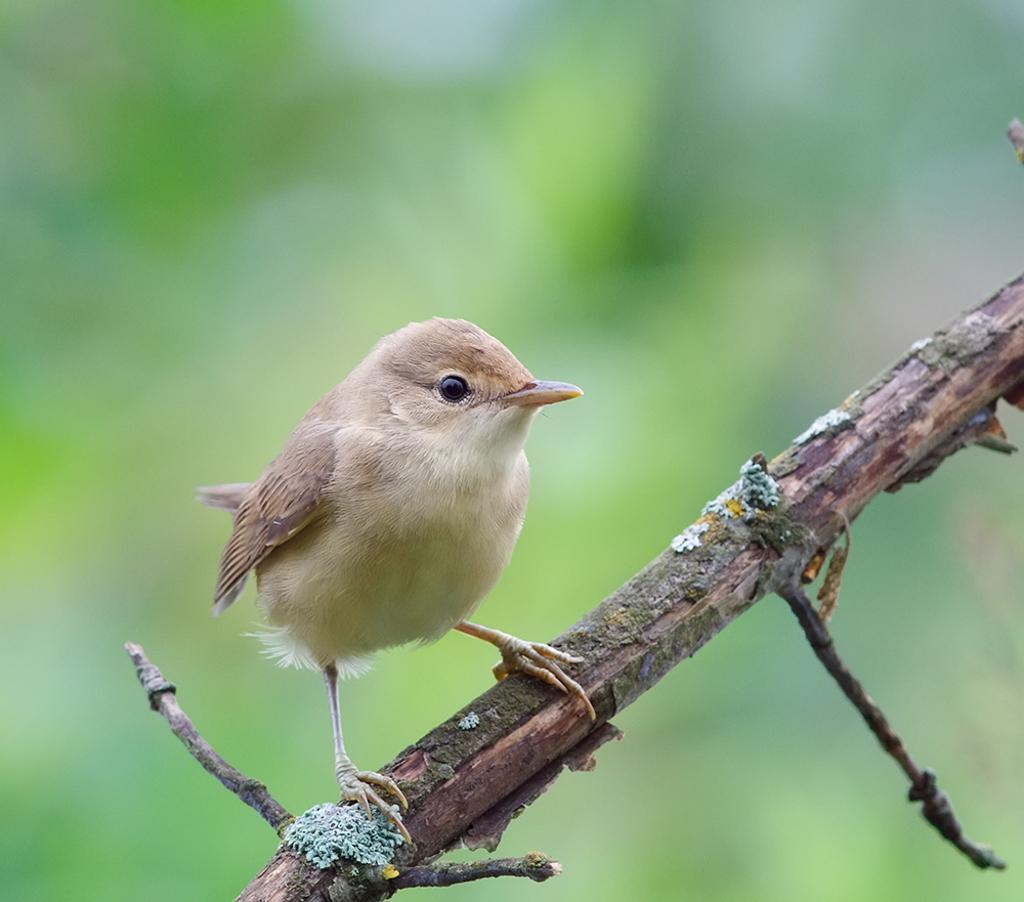In one or two sentences, can you explain what this image depicts? In this image I can see a stick in the front and on it I can see a white and cream colour bird. I can also see green colour in the background and I can see this image is blurry in the background. 